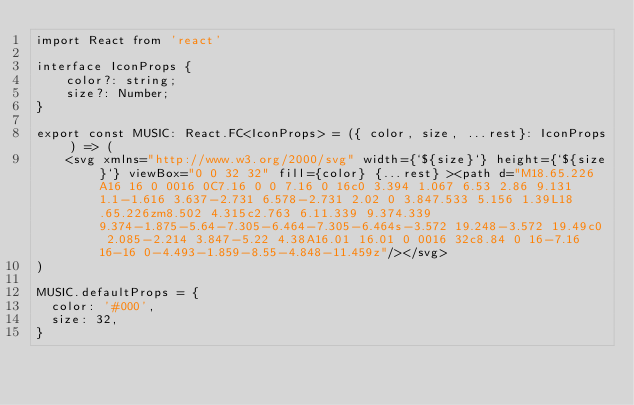Convert code to text. <code><loc_0><loc_0><loc_500><loc_500><_TypeScript_>import React from 'react'

interface IconProps {
    color?: string;
    size?: Number;
} 

export const MUSIC: React.FC<IconProps> = ({ color, size, ...rest}: IconProps) => (
    <svg xmlns="http://www.w3.org/2000/svg" width={`${size}`} height={`${size}`} viewBox="0 0 32 32" fill={color} {...rest} ><path d="M18.65.226A16 16 0 0016 0C7.16 0 0 7.16 0 16c0 3.394 1.067 6.53 2.86 9.131 1.1-1.616 3.637-2.731 6.578-2.731 2.02 0 3.847.533 5.156 1.39L18.65.226zm8.502 4.315c2.763 6.11.339 9.374.339 9.374-1.875-5.64-7.305-6.464-7.305-6.464s-3.572 19.248-3.572 19.49c0 2.085-2.214 3.847-5.22 4.38A16.01 16.01 0 0016 32c8.84 0 16-7.16 16-16 0-4.493-1.859-8.55-4.848-11.459z"/></svg>
)
          
MUSIC.defaultProps = {
  color: '#000',
  size: 32,
}
          </code> 